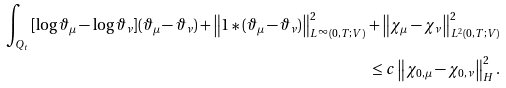Convert formula to latex. <formula><loc_0><loc_0><loc_500><loc_500>\int _ { Q _ { t } } { [ \log \vartheta _ { \mu } - \log \vartheta _ { \nu } ] ( \vartheta _ { \mu } - \vartheta _ { \nu } ) } + \left \| 1 \ast ( \vartheta _ { \mu } - \vartheta _ { \nu } ) \right \| ^ { 2 } _ { L ^ { \infty } ( 0 , T ; V ) } + \left \| \chi _ { \mu } - \chi _ { \nu } \right \| ^ { 2 } _ { L ^ { 2 } ( 0 , T ; V ) } \\ \leq c \left \| \chi _ { 0 , \mu } - \chi _ { 0 , \nu } \right \| ^ { 2 } _ { H } .</formula> 